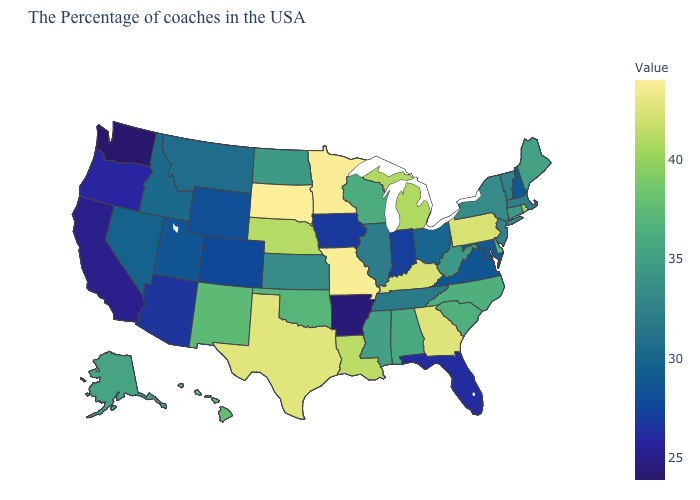Does Oregon have the lowest value in the West?
Give a very brief answer. No. Which states have the highest value in the USA?
Keep it brief. South Dakota. Among the states that border Idaho , which have the lowest value?
Short answer required. Washington. Does Washington have the lowest value in the USA?
Quick response, please. Yes. Does Montana have the highest value in the USA?
Concise answer only. No. 